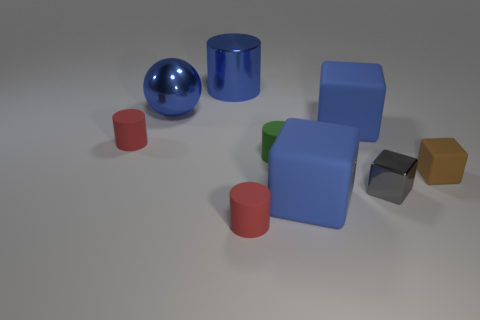There is a matte block behind the tiny red cylinder that is left of the red rubber thing in front of the small brown cube; what is its color?
Keep it short and to the point. Blue. Do the brown rubber cube and the gray block have the same size?
Your answer should be very brief. Yes. What number of other matte things are the same size as the green object?
Ensure brevity in your answer.  3. There is a large metal object that is the same color as the metallic cylinder; what shape is it?
Give a very brief answer. Sphere. Are the red cylinder behind the tiny green cylinder and the large blue cube behind the tiny green object made of the same material?
Offer a very short reply. Yes. Is there any other thing that has the same shape as the tiny gray thing?
Offer a very short reply. Yes. The metallic cylinder has what color?
Offer a very short reply. Blue. What number of tiny brown rubber things have the same shape as the green thing?
Provide a succinct answer. 0. There is a ball that is the same size as the blue shiny cylinder; what color is it?
Provide a succinct answer. Blue. Are any tiny things visible?
Keep it short and to the point. Yes. 